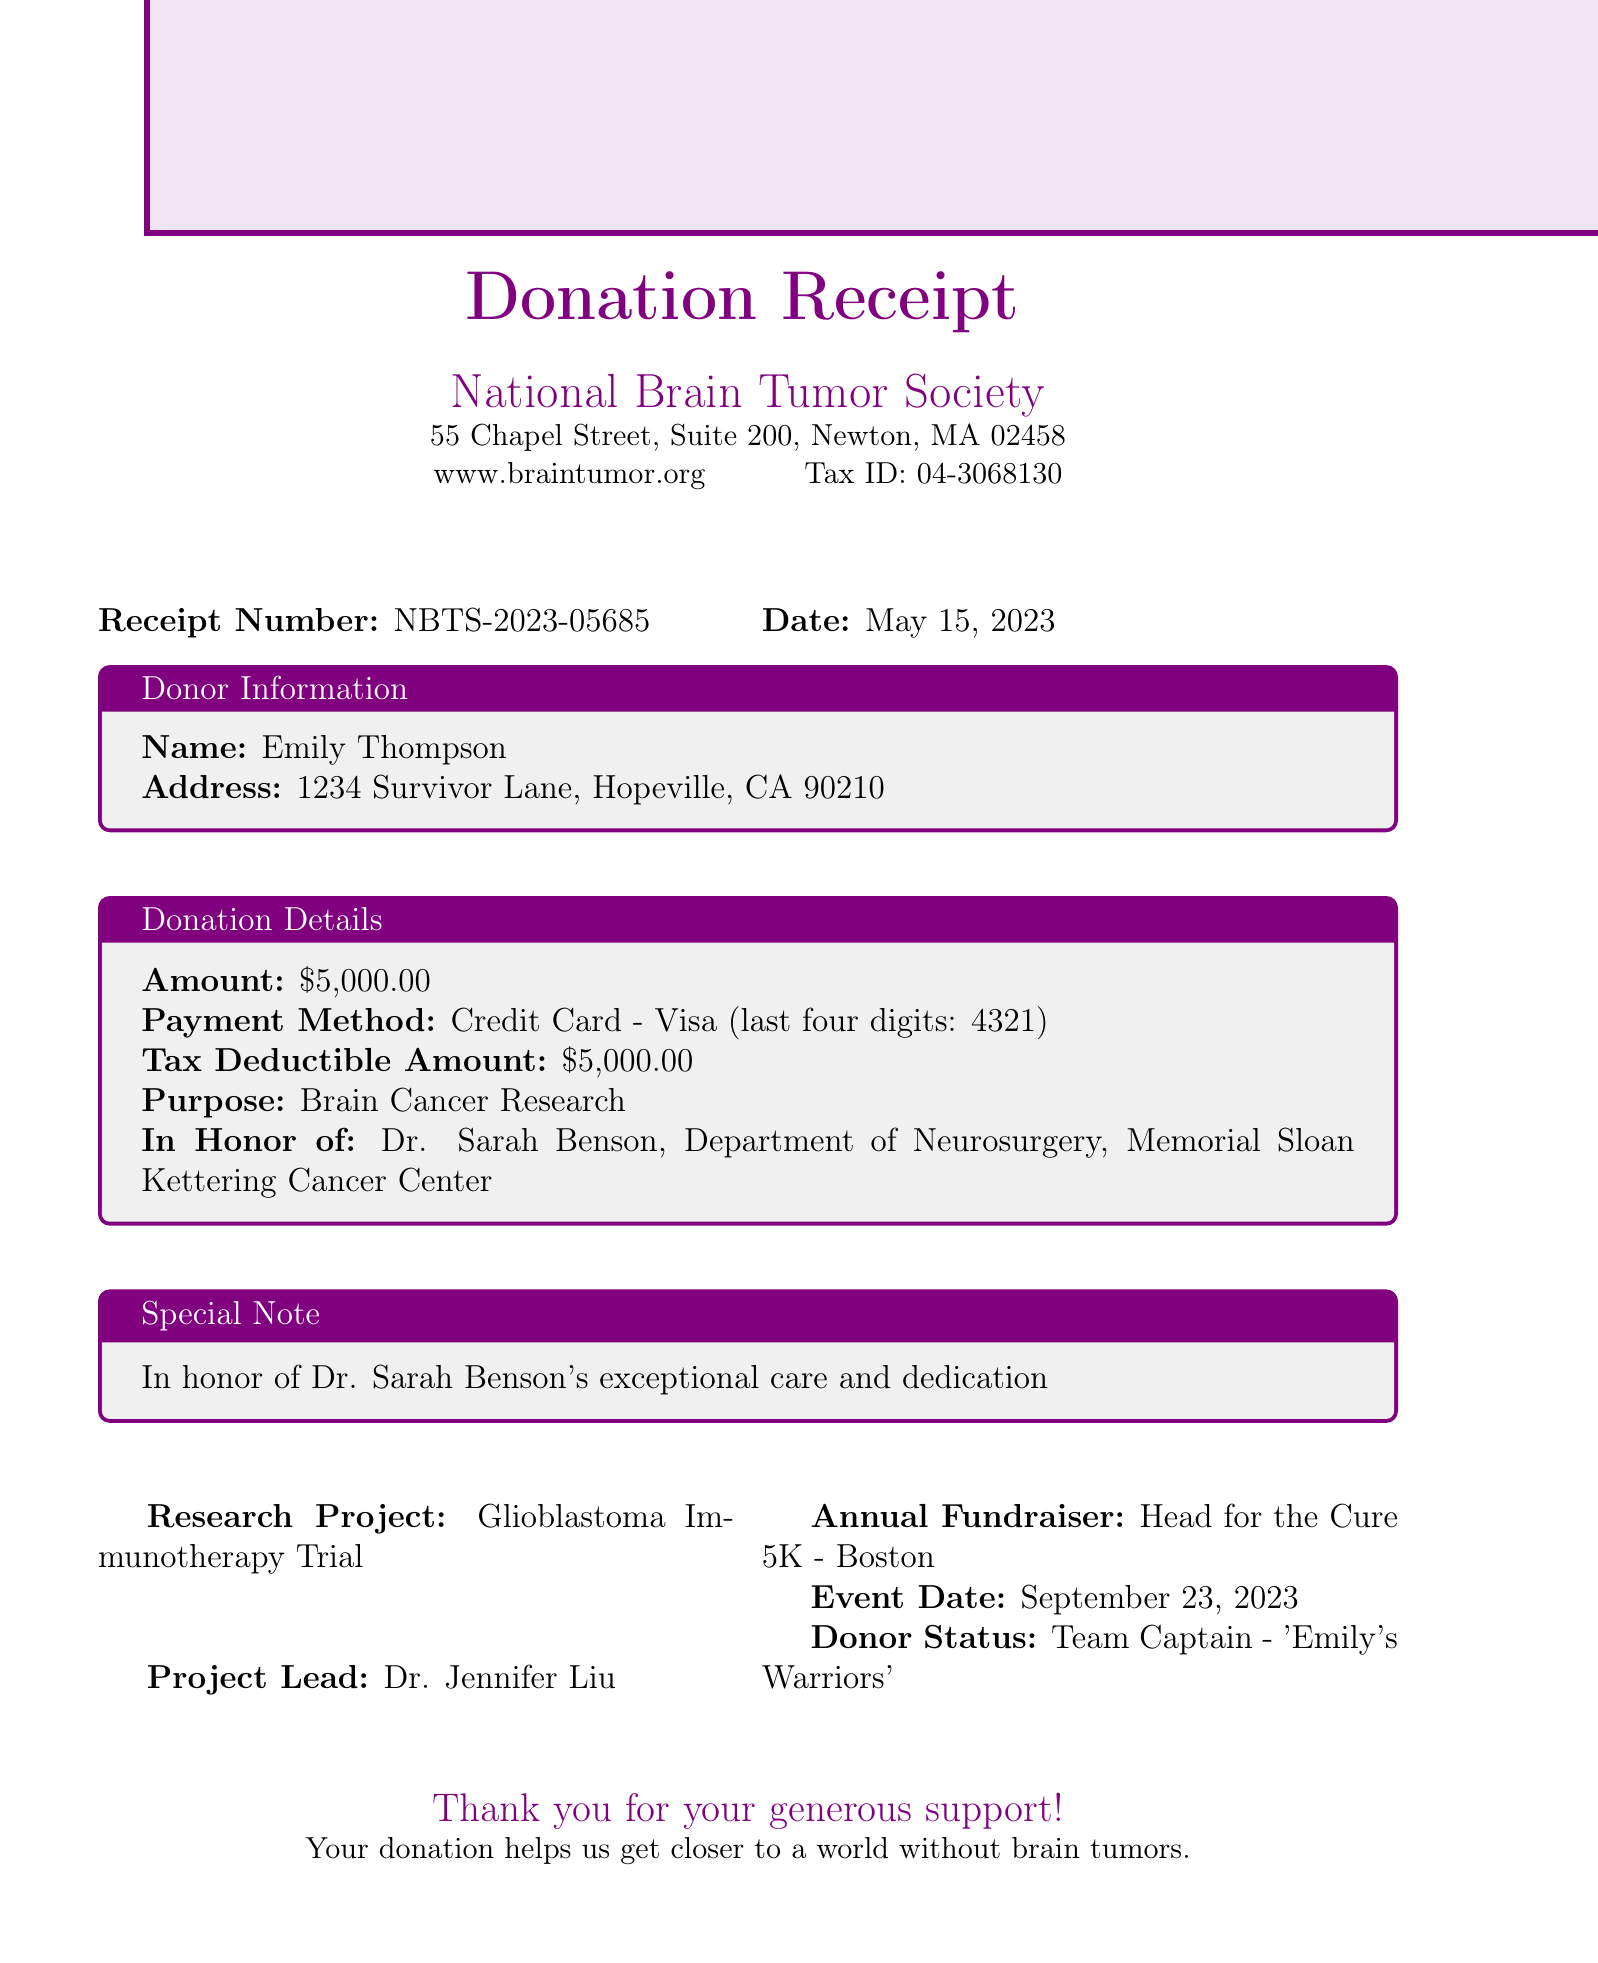What is the name of the donor? The name of the donor is listed at the top of the document.
Answer: Emily Thompson What is the donation amount? The donation amount is specified in the donation details section.
Answer: $5,000.00 What is the date of the donation? The date of the donation can be found in the receipt details section.
Answer: May 15, 2023 Who is being honored with this donation? The honoree is mentioned in the donation details and special note sections.
Answer: Dr. Sarah Benson What is the purpose of the donation? The purpose of the donation is clearly stated in the donation details section.
Answer: Brain Cancer Research What is the receipt number? The receipt number is prominently displayed at the beginning of the document.
Answer: NBTS-2023-05685 What event is mentioned in the document? The annual fundraiser event is specified in the research project section.
Answer: Head for the Cure 5K - Boston Who leads the research project mentioned? The project lead is noted in the research project details section.
Answer: Dr. Jennifer Liu What is the contact email for the foundation? The foundation's contact email is provided in the contact information section.
Answer: donations@braintumor.org 